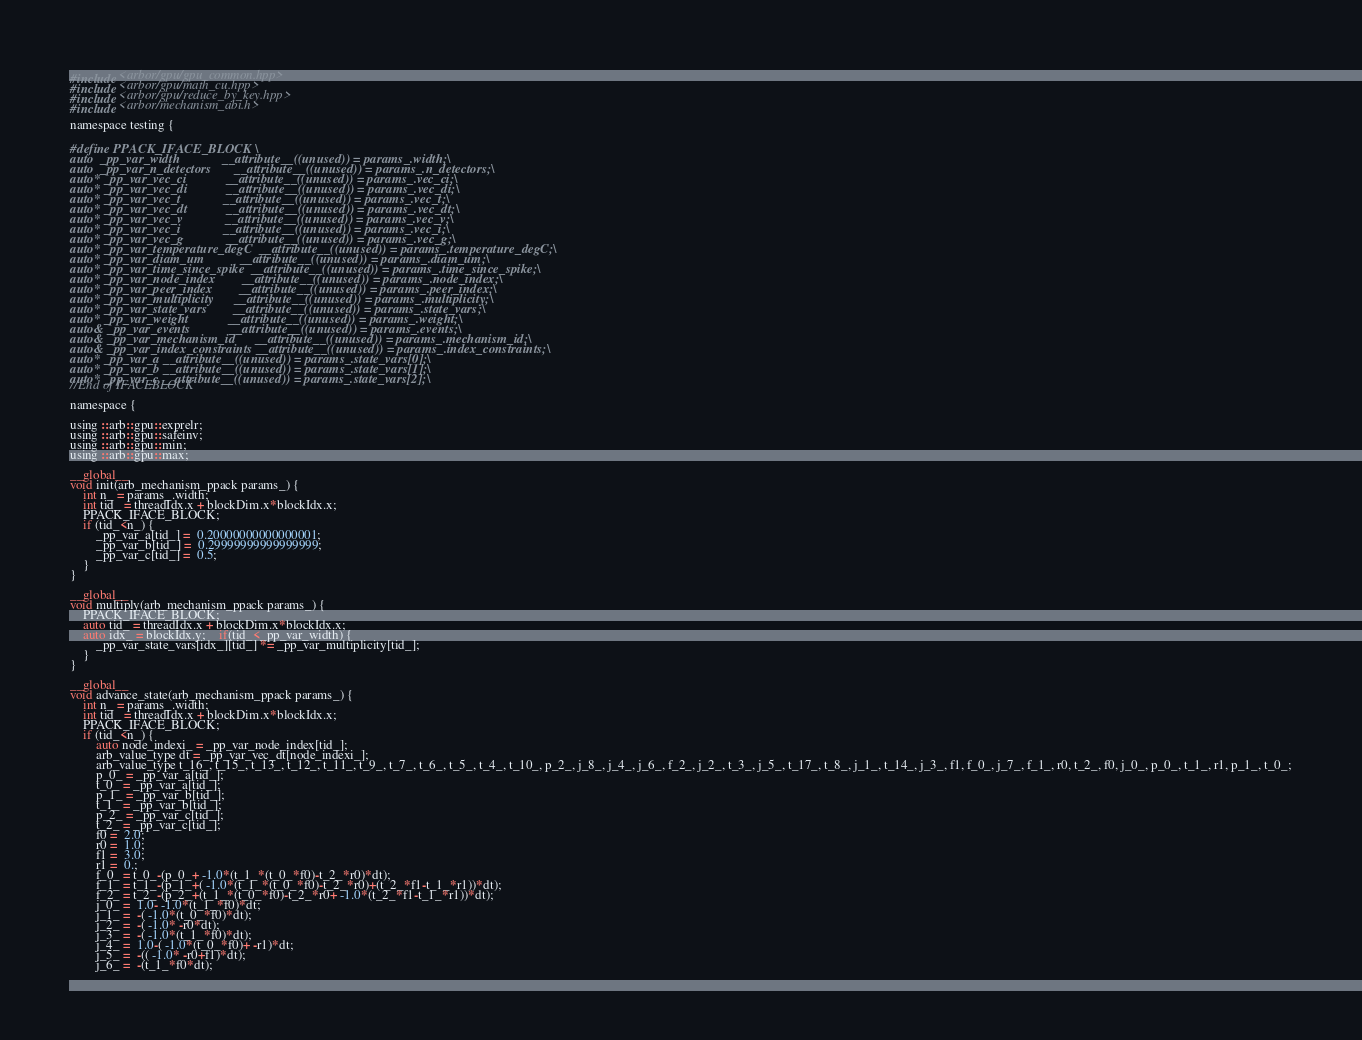Convert code to text. <code><loc_0><loc_0><loc_500><loc_500><_Cuda_>#include <arbor/gpu/gpu_common.hpp>
#include <arbor/gpu/math_cu.hpp>
#include <arbor/gpu/reduce_by_key.hpp>
#include <arbor/mechanism_abi.h>

namespace testing {

#define PPACK_IFACE_BLOCK \
auto  _pp_var_width             __attribute__((unused)) = params_.width;\
auto  _pp_var_n_detectors       __attribute__((unused)) = params_.n_detectors;\
auto* _pp_var_vec_ci            __attribute__((unused)) = params_.vec_ci;\
auto* _pp_var_vec_di            __attribute__((unused)) = params_.vec_di;\
auto* _pp_var_vec_t             __attribute__((unused)) = params_.vec_t;\
auto* _pp_var_vec_dt            __attribute__((unused)) = params_.vec_dt;\
auto* _pp_var_vec_v             __attribute__((unused)) = params_.vec_v;\
auto* _pp_var_vec_i             __attribute__((unused)) = params_.vec_i;\
auto* _pp_var_vec_g             __attribute__((unused)) = params_.vec_g;\
auto* _pp_var_temperature_degC  __attribute__((unused)) = params_.temperature_degC;\
auto* _pp_var_diam_um           __attribute__((unused)) = params_.diam_um;\
auto* _pp_var_time_since_spike  __attribute__((unused)) = params_.time_since_spike;\
auto* _pp_var_node_index        __attribute__((unused)) = params_.node_index;\
auto* _pp_var_peer_index        __attribute__((unused)) = params_.peer_index;\
auto* _pp_var_multiplicity      __attribute__((unused)) = params_.multiplicity;\
auto* _pp_var_state_vars        __attribute__((unused)) = params_.state_vars;\
auto* _pp_var_weight            __attribute__((unused)) = params_.weight;\
auto& _pp_var_events            __attribute__((unused)) = params_.events;\
auto& _pp_var_mechanism_id      __attribute__((unused)) = params_.mechanism_id;\
auto& _pp_var_index_constraints __attribute__((unused)) = params_.index_constraints;\
auto* _pp_var_a __attribute__((unused)) = params_.state_vars[0];\
auto* _pp_var_b __attribute__((unused)) = params_.state_vars[1];\
auto* _pp_var_c __attribute__((unused)) = params_.state_vars[2];\
//End of IFACEBLOCK

namespace {

using ::arb::gpu::exprelr;
using ::arb::gpu::safeinv;
using ::arb::gpu::min;
using ::arb::gpu::max;

__global__
void init(arb_mechanism_ppack params_) {
    int n_ = params_.width;
    int tid_ = threadIdx.x + blockDim.x*blockIdx.x;
    PPACK_IFACE_BLOCK;
    if (tid_<n_) {
        _pp_var_a[tid_] =  0.20000000000000001;
        _pp_var_b[tid_] =  0.29999999999999999;
        _pp_var_c[tid_] =  0.5;
    }
}

__global__
void multiply(arb_mechanism_ppack params_) {
    PPACK_IFACE_BLOCK;
    auto tid_ = threadIdx.x + blockDim.x*blockIdx.x;
    auto idx_ = blockIdx.y;    if(tid_<_pp_var_width) {
        _pp_var_state_vars[idx_][tid_] *= _pp_var_multiplicity[tid_];
    }
}

__global__
void advance_state(arb_mechanism_ppack params_) {
    int n_ = params_.width;
    int tid_ = threadIdx.x + blockDim.x*blockIdx.x;
    PPACK_IFACE_BLOCK;
    if (tid_<n_) {
        auto node_indexi_ = _pp_var_node_index[tid_];
        arb_value_type dt = _pp_var_vec_dt[node_indexi_];
        arb_value_type t_16_, t_15_, t_13_, t_12_, t_11_, t_9_, t_7_, t_6_, t_5_, t_4_, t_10_, p_2_, j_8_, j_4_, j_6_, f_2_, j_2_, t_3_, j_5_, t_17_, t_8_, j_1_, t_14_, j_3_, f1, f_0_, j_7_, f_1_, r0, t_2_, f0, j_0_, p_0_, t_1_, r1, p_1_, t_0_;
        p_0_ = _pp_var_a[tid_];
        t_0_ = _pp_var_a[tid_];
        p_1_ = _pp_var_b[tid_];
        t_1_ = _pp_var_b[tid_];
        p_2_ = _pp_var_c[tid_];
        t_2_ = _pp_var_c[tid_];
        f0 =  2.0;
        r0 =  1.0;
        f1 =  3.0;
        r1 =  0.;
        f_0_ = t_0_-(p_0_+ -1.0*(t_1_*(t_0_*f0)-t_2_*r0)*dt);
        f_1_ = t_1_-(p_1_+( -1.0*(t_1_*(t_0_*f0)-t_2_*r0)+(t_2_*f1-t_1_*r1))*dt);
        f_2_ = t_2_-(p_2_+(t_1_*(t_0_*f0)-t_2_*r0+ -1.0*(t_2_*f1-t_1_*r1))*dt);
        j_0_ =  1.0- -1.0*(t_1_*f0)*dt;
        j_1_ =  -( -1.0*(t_0_*f0)*dt);
        j_2_ =  -( -1.0* -r0*dt);
        j_3_ =  -( -1.0*(t_1_*f0)*dt);
        j_4_ =  1.0-( -1.0*(t_0_*f0)+ -r1)*dt;
        j_5_ =  -(( -1.0* -r0+f1)*dt);
        j_6_ =  -(t_1_*f0*dt);</code> 